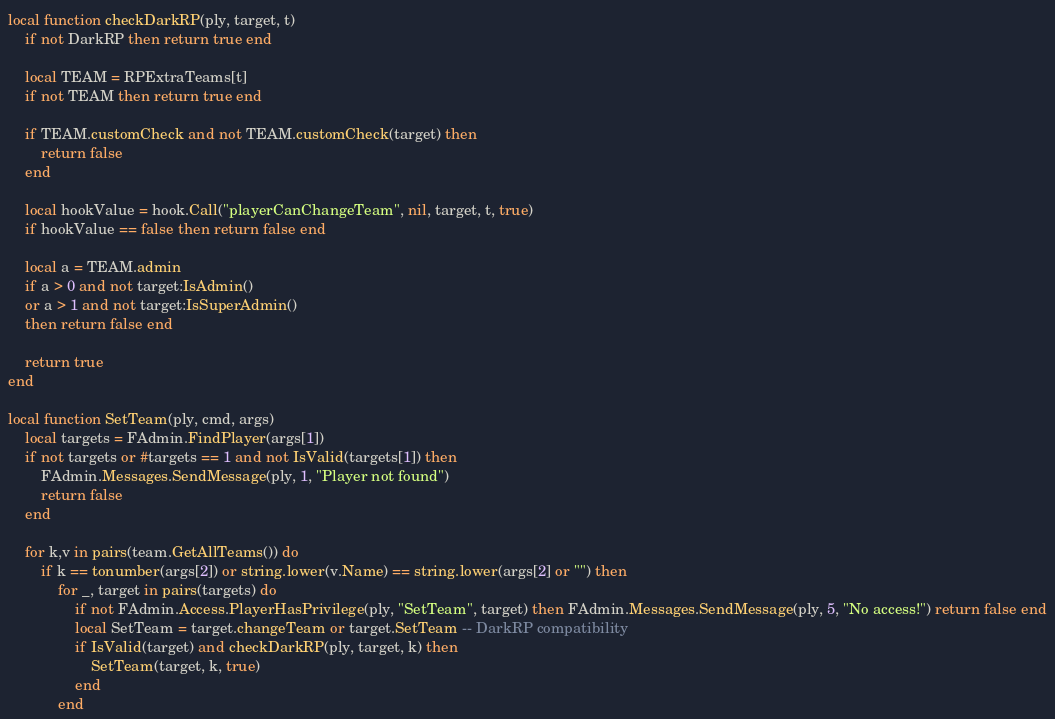Convert code to text. <code><loc_0><loc_0><loc_500><loc_500><_Lua_>local function checkDarkRP(ply, target, t)
	if not DarkRP then return true end

	local TEAM = RPExtraTeams[t]
	if not TEAM then return true end

	if TEAM.customCheck and not TEAM.customCheck(target) then
		return false
	end

	local hookValue = hook.Call("playerCanChangeTeam", nil, target, t, true)
	if hookValue == false then return false end

	local a = TEAM.admin
	if a > 0 and not target:IsAdmin()
	or a > 1 and not target:IsSuperAdmin()
	then return false end

	return true
end

local function SetTeam(ply, cmd, args)
	local targets = FAdmin.FindPlayer(args[1])
	if not targets or #targets == 1 and not IsValid(targets[1]) then
		FAdmin.Messages.SendMessage(ply, 1, "Player not found")
		return false
	end

	for k,v in pairs(team.GetAllTeams()) do
		if k == tonumber(args[2]) or string.lower(v.Name) == string.lower(args[2] or "") then
			for _, target in pairs(targets) do
				if not FAdmin.Access.PlayerHasPrivilege(ply, "SetTeam", target) then FAdmin.Messages.SendMessage(ply, 5, "No access!") return false end
				local SetTeam = target.changeTeam or target.SetTeam -- DarkRP compatibility
				if IsValid(target) and checkDarkRP(ply, target, k) then
					SetTeam(target, k, true)
				end
			end</code> 